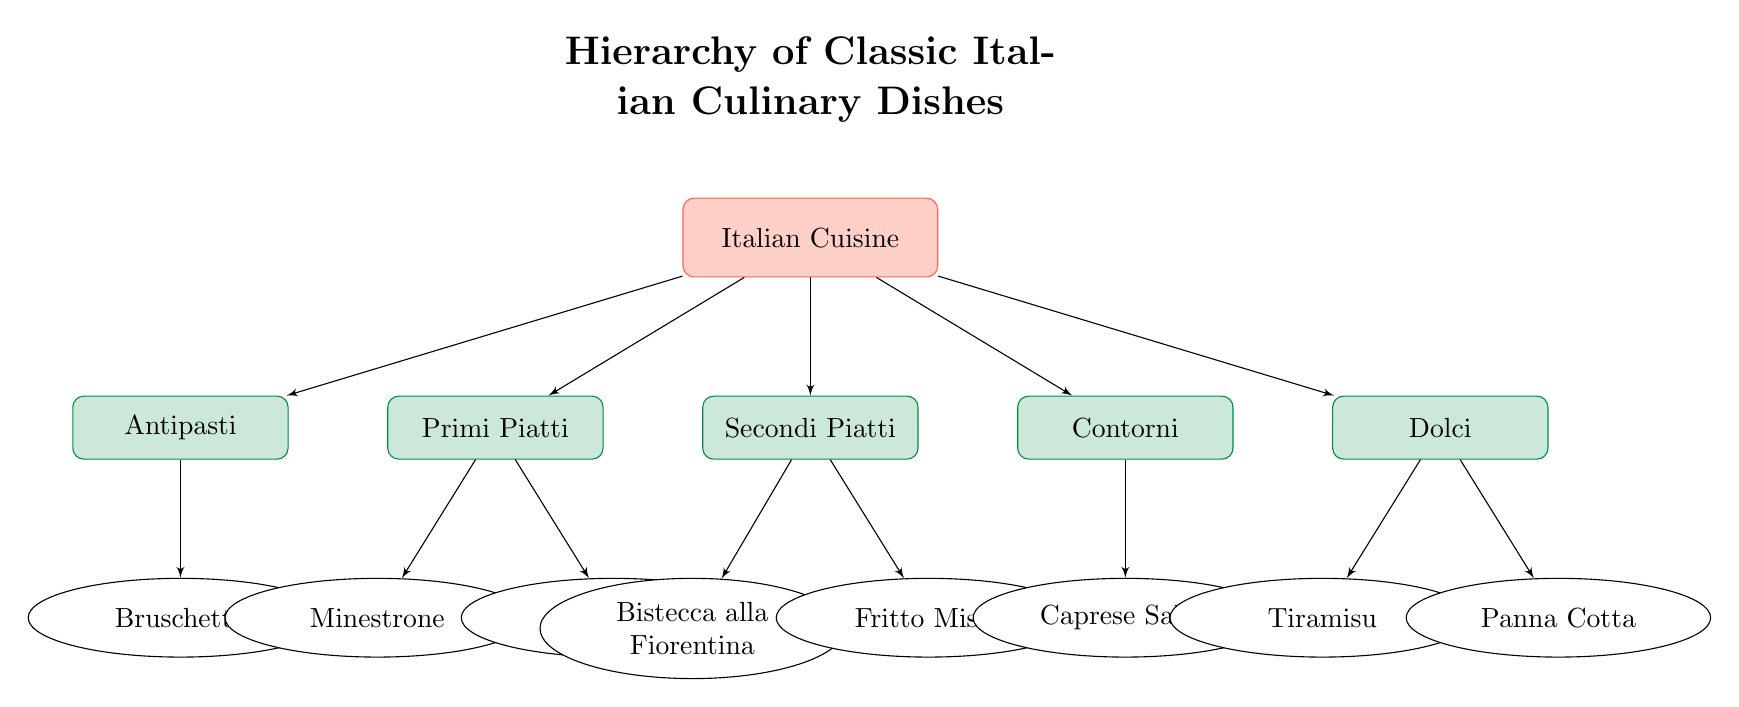What is the top-level category in this hierarchy? The top-level category is indicated at the highest position in the diagram, which is labeled "Italian Cuisine."
Answer: Italian Cuisine How many types of dishes are listed under the second-level categories? By counting the second-level categories (Antipasti, Primi Piatti, Secondi Piatti, Contorni, and Dolci), there are five in total.
Answer: 5 Which dish is listed under Antipasti? The diagram shows only one dish under Antipasti, which is labeled as "Bruschetta."
Answer: Bruschetta What are two examples of dishes in the second-level category Secondi Piatti? Within the Secondi Piatti category, the two examples of dishes listed are "Bistecca alla Fiorentina" and "Fritto Misto."
Answer: Bistecca alla Fiorentina, Fritto Misto How many dishes fall under the Primi Piatti category? The Primi Piatti category includes two dishes: "Minestrone" and "Lasagna," therefore there are two dishes.
Answer: 2 Which category contains the dish Panna Cotta? The dish "Panna Cotta" is found in the Dolci category, which is evident from its position in the diagram.
Answer: Dolci Which has a greater number of dishes, Contorni or Secondi Piatti? Upon analyzing the diagram, the Secondi Piatti category includes two dishes, while the Contorni category has only one dish, "Caprese Salad," indicating Secondi Piatti has more.
Answer: Secondi Piatti What shape represents the dish categories at the third level? The third-level categories containing the specific dishes are represented using the shape of ellipses according to the diagram’s coding.
Answer: Ellipse 